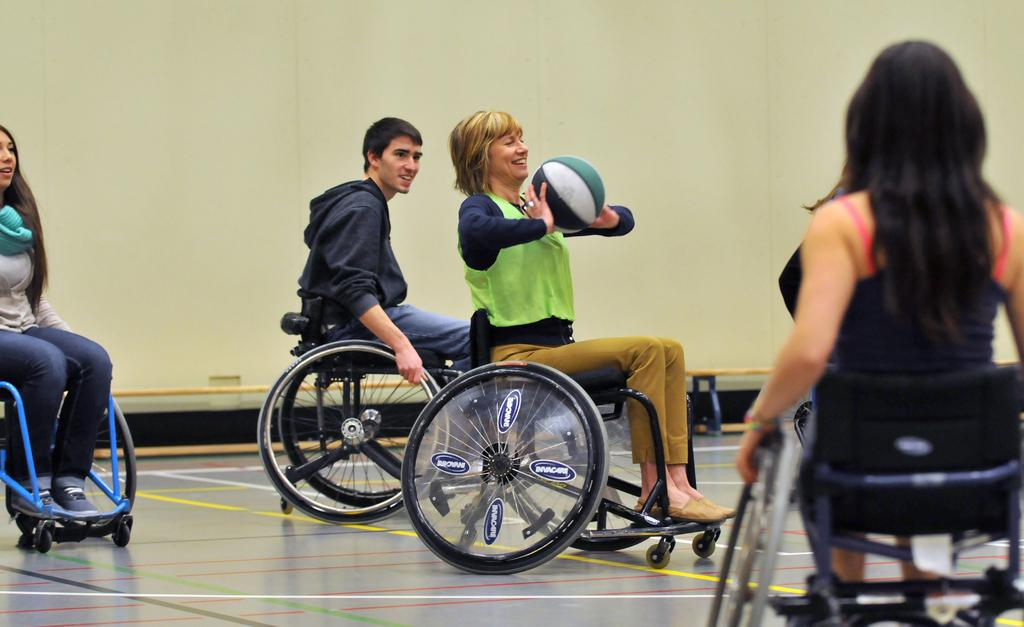How many persons are in the image? There are persons in the image. What are the persons wearing? The persons are wearing clothes. What are the persons using to sit? The persons are sitting on wheelchairs. Can you describe the person in the middle of the image? The person in the middle is holding a ball with her hands. What type of harmony is being played by the stranger in the image? There is no stranger or harmony present in the image. What type of authority is the person in the middle of the image representing? The person in the middle of the image is not representing any authority; she is simply holding a ball. 